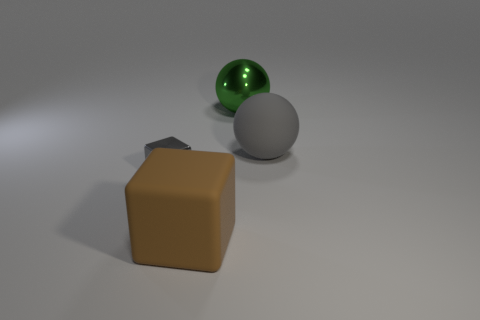Add 2 big brown matte things. How many objects exist? 6 Subtract all gray cubes. How many cubes are left? 1 Subtract 2 cubes. How many cubes are left? 0 Subtract all yellow balls. Subtract all green cylinders. How many balls are left? 2 Add 4 tiny shiny things. How many tiny shiny things are left? 5 Add 3 matte things. How many matte things exist? 5 Subtract 0 brown spheres. How many objects are left? 4 Subtract all tiny rubber objects. Subtract all matte cubes. How many objects are left? 3 